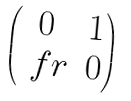<formula> <loc_0><loc_0><loc_500><loc_500>\begin{pmatrix} 0 & 1 \\ \ f r & 0 \end{pmatrix}</formula> 